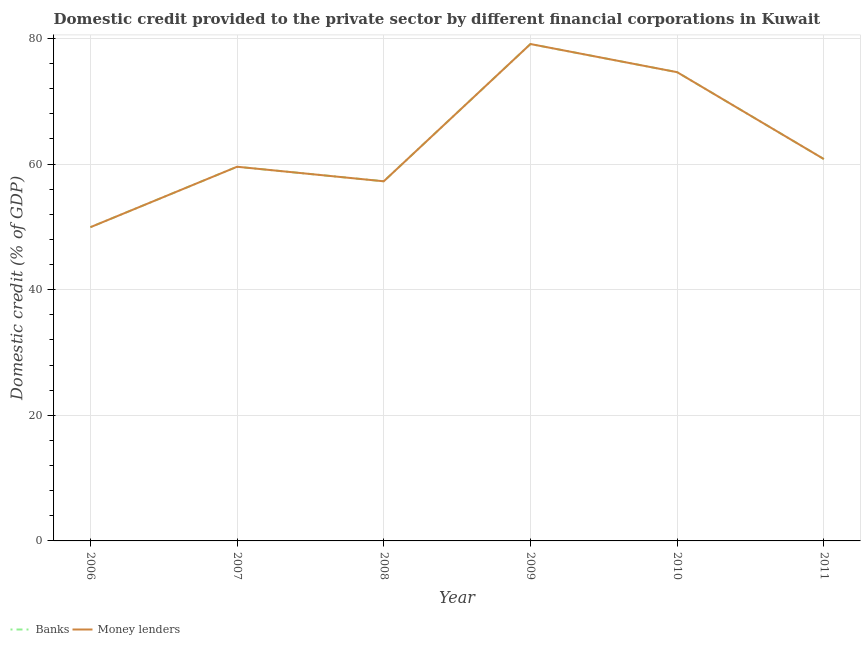Is the number of lines equal to the number of legend labels?
Provide a short and direct response. Yes. What is the domestic credit provided by banks in 2008?
Your answer should be very brief. 57.26. Across all years, what is the maximum domestic credit provided by banks?
Make the answer very short. 79.12. Across all years, what is the minimum domestic credit provided by banks?
Keep it short and to the point. 49.95. In which year was the domestic credit provided by banks maximum?
Make the answer very short. 2009. What is the total domestic credit provided by money lenders in the graph?
Your response must be concise. 381.36. What is the difference between the domestic credit provided by banks in 2006 and that in 2010?
Your response must be concise. -24.69. What is the difference between the domestic credit provided by banks in 2011 and the domestic credit provided by money lenders in 2007?
Offer a terse response. 1.23. What is the average domestic credit provided by banks per year?
Your answer should be compact. 63.56. In the year 2009, what is the difference between the domestic credit provided by banks and domestic credit provided by money lenders?
Make the answer very short. 0. What is the ratio of the domestic credit provided by banks in 2007 to that in 2010?
Your answer should be compact. 0.8. Is the domestic credit provided by money lenders in 2009 less than that in 2010?
Your answer should be compact. No. Is the difference between the domestic credit provided by banks in 2007 and 2011 greater than the difference between the domestic credit provided by money lenders in 2007 and 2011?
Keep it short and to the point. No. What is the difference between the highest and the second highest domestic credit provided by money lenders?
Make the answer very short. 4.48. What is the difference between the highest and the lowest domestic credit provided by money lenders?
Offer a very short reply. 29.17. In how many years, is the domestic credit provided by banks greater than the average domestic credit provided by banks taken over all years?
Your answer should be very brief. 2. Is the sum of the domestic credit provided by banks in 2007 and 2009 greater than the maximum domestic credit provided by money lenders across all years?
Ensure brevity in your answer.  Yes. Does the domestic credit provided by banks monotonically increase over the years?
Your response must be concise. No. Is the domestic credit provided by banks strictly greater than the domestic credit provided by money lenders over the years?
Give a very brief answer. No. Is the domestic credit provided by banks strictly less than the domestic credit provided by money lenders over the years?
Keep it short and to the point. No. How many lines are there?
Your response must be concise. 2. How many years are there in the graph?
Your answer should be very brief. 6. What is the difference between two consecutive major ticks on the Y-axis?
Provide a succinct answer. 20. Are the values on the major ticks of Y-axis written in scientific E-notation?
Ensure brevity in your answer.  No. Does the graph contain any zero values?
Make the answer very short. No. Where does the legend appear in the graph?
Provide a short and direct response. Bottom left. How are the legend labels stacked?
Your response must be concise. Horizontal. What is the title of the graph?
Offer a terse response. Domestic credit provided to the private sector by different financial corporations in Kuwait. What is the label or title of the X-axis?
Provide a short and direct response. Year. What is the label or title of the Y-axis?
Offer a very short reply. Domestic credit (% of GDP). What is the Domestic credit (% of GDP) of Banks in 2006?
Your answer should be compact. 49.95. What is the Domestic credit (% of GDP) in Money lenders in 2006?
Offer a very short reply. 49.95. What is the Domestic credit (% of GDP) of Banks in 2007?
Offer a terse response. 59.58. What is the Domestic credit (% of GDP) in Money lenders in 2007?
Your answer should be very brief. 59.58. What is the Domestic credit (% of GDP) in Banks in 2008?
Provide a short and direct response. 57.26. What is the Domestic credit (% of GDP) of Money lenders in 2008?
Give a very brief answer. 57.26. What is the Domestic credit (% of GDP) of Banks in 2009?
Offer a very short reply. 79.12. What is the Domestic credit (% of GDP) of Money lenders in 2009?
Provide a short and direct response. 79.12. What is the Domestic credit (% of GDP) of Banks in 2010?
Offer a terse response. 74.64. What is the Domestic credit (% of GDP) in Money lenders in 2010?
Provide a short and direct response. 74.64. What is the Domestic credit (% of GDP) of Banks in 2011?
Your response must be concise. 60.81. What is the Domestic credit (% of GDP) of Money lenders in 2011?
Make the answer very short. 60.81. Across all years, what is the maximum Domestic credit (% of GDP) in Banks?
Make the answer very short. 79.12. Across all years, what is the maximum Domestic credit (% of GDP) of Money lenders?
Give a very brief answer. 79.12. Across all years, what is the minimum Domestic credit (% of GDP) of Banks?
Provide a succinct answer. 49.95. Across all years, what is the minimum Domestic credit (% of GDP) in Money lenders?
Keep it short and to the point. 49.95. What is the total Domestic credit (% of GDP) of Banks in the graph?
Your answer should be compact. 381.36. What is the total Domestic credit (% of GDP) of Money lenders in the graph?
Offer a terse response. 381.36. What is the difference between the Domestic credit (% of GDP) in Banks in 2006 and that in 2007?
Offer a terse response. -9.63. What is the difference between the Domestic credit (% of GDP) of Money lenders in 2006 and that in 2007?
Give a very brief answer. -9.63. What is the difference between the Domestic credit (% of GDP) in Banks in 2006 and that in 2008?
Give a very brief answer. -7.31. What is the difference between the Domestic credit (% of GDP) in Money lenders in 2006 and that in 2008?
Give a very brief answer. -7.31. What is the difference between the Domestic credit (% of GDP) of Banks in 2006 and that in 2009?
Offer a terse response. -29.17. What is the difference between the Domestic credit (% of GDP) of Money lenders in 2006 and that in 2009?
Make the answer very short. -29.17. What is the difference between the Domestic credit (% of GDP) of Banks in 2006 and that in 2010?
Provide a short and direct response. -24.69. What is the difference between the Domestic credit (% of GDP) of Money lenders in 2006 and that in 2010?
Give a very brief answer. -24.69. What is the difference between the Domestic credit (% of GDP) of Banks in 2006 and that in 2011?
Keep it short and to the point. -10.85. What is the difference between the Domestic credit (% of GDP) in Money lenders in 2006 and that in 2011?
Offer a terse response. -10.85. What is the difference between the Domestic credit (% of GDP) in Banks in 2007 and that in 2008?
Provide a short and direct response. 2.31. What is the difference between the Domestic credit (% of GDP) of Money lenders in 2007 and that in 2008?
Offer a very short reply. 2.31. What is the difference between the Domestic credit (% of GDP) in Banks in 2007 and that in 2009?
Give a very brief answer. -19.54. What is the difference between the Domestic credit (% of GDP) in Money lenders in 2007 and that in 2009?
Your answer should be very brief. -19.54. What is the difference between the Domestic credit (% of GDP) of Banks in 2007 and that in 2010?
Give a very brief answer. -15.06. What is the difference between the Domestic credit (% of GDP) of Money lenders in 2007 and that in 2010?
Your answer should be compact. -15.06. What is the difference between the Domestic credit (% of GDP) of Banks in 2007 and that in 2011?
Provide a succinct answer. -1.23. What is the difference between the Domestic credit (% of GDP) in Money lenders in 2007 and that in 2011?
Keep it short and to the point. -1.23. What is the difference between the Domestic credit (% of GDP) in Banks in 2008 and that in 2009?
Your answer should be compact. -21.85. What is the difference between the Domestic credit (% of GDP) of Money lenders in 2008 and that in 2009?
Your response must be concise. -21.85. What is the difference between the Domestic credit (% of GDP) of Banks in 2008 and that in 2010?
Keep it short and to the point. -17.37. What is the difference between the Domestic credit (% of GDP) in Money lenders in 2008 and that in 2010?
Keep it short and to the point. -17.37. What is the difference between the Domestic credit (% of GDP) in Banks in 2008 and that in 2011?
Ensure brevity in your answer.  -3.54. What is the difference between the Domestic credit (% of GDP) in Money lenders in 2008 and that in 2011?
Provide a succinct answer. -3.54. What is the difference between the Domestic credit (% of GDP) in Banks in 2009 and that in 2010?
Make the answer very short. 4.48. What is the difference between the Domestic credit (% of GDP) in Money lenders in 2009 and that in 2010?
Make the answer very short. 4.48. What is the difference between the Domestic credit (% of GDP) in Banks in 2009 and that in 2011?
Your answer should be compact. 18.31. What is the difference between the Domestic credit (% of GDP) of Money lenders in 2009 and that in 2011?
Provide a succinct answer. 18.31. What is the difference between the Domestic credit (% of GDP) in Banks in 2010 and that in 2011?
Offer a very short reply. 13.83. What is the difference between the Domestic credit (% of GDP) in Money lenders in 2010 and that in 2011?
Give a very brief answer. 13.83. What is the difference between the Domestic credit (% of GDP) in Banks in 2006 and the Domestic credit (% of GDP) in Money lenders in 2007?
Offer a very short reply. -9.63. What is the difference between the Domestic credit (% of GDP) in Banks in 2006 and the Domestic credit (% of GDP) in Money lenders in 2008?
Your answer should be compact. -7.31. What is the difference between the Domestic credit (% of GDP) in Banks in 2006 and the Domestic credit (% of GDP) in Money lenders in 2009?
Your answer should be compact. -29.17. What is the difference between the Domestic credit (% of GDP) in Banks in 2006 and the Domestic credit (% of GDP) in Money lenders in 2010?
Ensure brevity in your answer.  -24.69. What is the difference between the Domestic credit (% of GDP) of Banks in 2006 and the Domestic credit (% of GDP) of Money lenders in 2011?
Your answer should be compact. -10.85. What is the difference between the Domestic credit (% of GDP) in Banks in 2007 and the Domestic credit (% of GDP) in Money lenders in 2008?
Your response must be concise. 2.31. What is the difference between the Domestic credit (% of GDP) of Banks in 2007 and the Domestic credit (% of GDP) of Money lenders in 2009?
Your answer should be compact. -19.54. What is the difference between the Domestic credit (% of GDP) in Banks in 2007 and the Domestic credit (% of GDP) in Money lenders in 2010?
Your response must be concise. -15.06. What is the difference between the Domestic credit (% of GDP) in Banks in 2007 and the Domestic credit (% of GDP) in Money lenders in 2011?
Offer a terse response. -1.23. What is the difference between the Domestic credit (% of GDP) of Banks in 2008 and the Domestic credit (% of GDP) of Money lenders in 2009?
Offer a terse response. -21.85. What is the difference between the Domestic credit (% of GDP) in Banks in 2008 and the Domestic credit (% of GDP) in Money lenders in 2010?
Make the answer very short. -17.37. What is the difference between the Domestic credit (% of GDP) in Banks in 2008 and the Domestic credit (% of GDP) in Money lenders in 2011?
Ensure brevity in your answer.  -3.54. What is the difference between the Domestic credit (% of GDP) in Banks in 2009 and the Domestic credit (% of GDP) in Money lenders in 2010?
Your answer should be compact. 4.48. What is the difference between the Domestic credit (% of GDP) in Banks in 2009 and the Domestic credit (% of GDP) in Money lenders in 2011?
Ensure brevity in your answer.  18.31. What is the difference between the Domestic credit (% of GDP) in Banks in 2010 and the Domestic credit (% of GDP) in Money lenders in 2011?
Keep it short and to the point. 13.83. What is the average Domestic credit (% of GDP) of Banks per year?
Your answer should be compact. 63.56. What is the average Domestic credit (% of GDP) in Money lenders per year?
Make the answer very short. 63.56. In the year 2006, what is the difference between the Domestic credit (% of GDP) of Banks and Domestic credit (% of GDP) of Money lenders?
Your response must be concise. 0. In the year 2007, what is the difference between the Domestic credit (% of GDP) in Banks and Domestic credit (% of GDP) in Money lenders?
Provide a short and direct response. 0. In the year 2008, what is the difference between the Domestic credit (% of GDP) in Banks and Domestic credit (% of GDP) in Money lenders?
Give a very brief answer. 0. In the year 2009, what is the difference between the Domestic credit (% of GDP) in Banks and Domestic credit (% of GDP) in Money lenders?
Provide a succinct answer. 0. In the year 2010, what is the difference between the Domestic credit (% of GDP) of Banks and Domestic credit (% of GDP) of Money lenders?
Your answer should be compact. 0. In the year 2011, what is the difference between the Domestic credit (% of GDP) of Banks and Domestic credit (% of GDP) of Money lenders?
Provide a succinct answer. 0. What is the ratio of the Domestic credit (% of GDP) in Banks in 2006 to that in 2007?
Provide a succinct answer. 0.84. What is the ratio of the Domestic credit (% of GDP) in Money lenders in 2006 to that in 2007?
Provide a succinct answer. 0.84. What is the ratio of the Domestic credit (% of GDP) in Banks in 2006 to that in 2008?
Give a very brief answer. 0.87. What is the ratio of the Domestic credit (% of GDP) in Money lenders in 2006 to that in 2008?
Your answer should be very brief. 0.87. What is the ratio of the Domestic credit (% of GDP) in Banks in 2006 to that in 2009?
Your response must be concise. 0.63. What is the ratio of the Domestic credit (% of GDP) in Money lenders in 2006 to that in 2009?
Ensure brevity in your answer.  0.63. What is the ratio of the Domestic credit (% of GDP) in Banks in 2006 to that in 2010?
Make the answer very short. 0.67. What is the ratio of the Domestic credit (% of GDP) of Money lenders in 2006 to that in 2010?
Give a very brief answer. 0.67. What is the ratio of the Domestic credit (% of GDP) in Banks in 2006 to that in 2011?
Offer a terse response. 0.82. What is the ratio of the Domestic credit (% of GDP) in Money lenders in 2006 to that in 2011?
Keep it short and to the point. 0.82. What is the ratio of the Domestic credit (% of GDP) of Banks in 2007 to that in 2008?
Keep it short and to the point. 1.04. What is the ratio of the Domestic credit (% of GDP) of Money lenders in 2007 to that in 2008?
Provide a short and direct response. 1.04. What is the ratio of the Domestic credit (% of GDP) in Banks in 2007 to that in 2009?
Ensure brevity in your answer.  0.75. What is the ratio of the Domestic credit (% of GDP) of Money lenders in 2007 to that in 2009?
Provide a succinct answer. 0.75. What is the ratio of the Domestic credit (% of GDP) in Banks in 2007 to that in 2010?
Offer a very short reply. 0.8. What is the ratio of the Domestic credit (% of GDP) of Money lenders in 2007 to that in 2010?
Your response must be concise. 0.8. What is the ratio of the Domestic credit (% of GDP) of Banks in 2007 to that in 2011?
Provide a short and direct response. 0.98. What is the ratio of the Domestic credit (% of GDP) in Money lenders in 2007 to that in 2011?
Make the answer very short. 0.98. What is the ratio of the Domestic credit (% of GDP) of Banks in 2008 to that in 2009?
Your answer should be compact. 0.72. What is the ratio of the Domestic credit (% of GDP) in Money lenders in 2008 to that in 2009?
Keep it short and to the point. 0.72. What is the ratio of the Domestic credit (% of GDP) in Banks in 2008 to that in 2010?
Keep it short and to the point. 0.77. What is the ratio of the Domestic credit (% of GDP) of Money lenders in 2008 to that in 2010?
Your response must be concise. 0.77. What is the ratio of the Domestic credit (% of GDP) of Banks in 2008 to that in 2011?
Offer a very short reply. 0.94. What is the ratio of the Domestic credit (% of GDP) in Money lenders in 2008 to that in 2011?
Your answer should be compact. 0.94. What is the ratio of the Domestic credit (% of GDP) of Banks in 2009 to that in 2010?
Offer a very short reply. 1.06. What is the ratio of the Domestic credit (% of GDP) of Money lenders in 2009 to that in 2010?
Your answer should be very brief. 1.06. What is the ratio of the Domestic credit (% of GDP) in Banks in 2009 to that in 2011?
Offer a very short reply. 1.3. What is the ratio of the Domestic credit (% of GDP) of Money lenders in 2009 to that in 2011?
Give a very brief answer. 1.3. What is the ratio of the Domestic credit (% of GDP) in Banks in 2010 to that in 2011?
Your answer should be compact. 1.23. What is the ratio of the Domestic credit (% of GDP) in Money lenders in 2010 to that in 2011?
Provide a succinct answer. 1.23. What is the difference between the highest and the second highest Domestic credit (% of GDP) in Banks?
Ensure brevity in your answer.  4.48. What is the difference between the highest and the second highest Domestic credit (% of GDP) in Money lenders?
Give a very brief answer. 4.48. What is the difference between the highest and the lowest Domestic credit (% of GDP) in Banks?
Your answer should be compact. 29.17. What is the difference between the highest and the lowest Domestic credit (% of GDP) of Money lenders?
Provide a succinct answer. 29.17. 